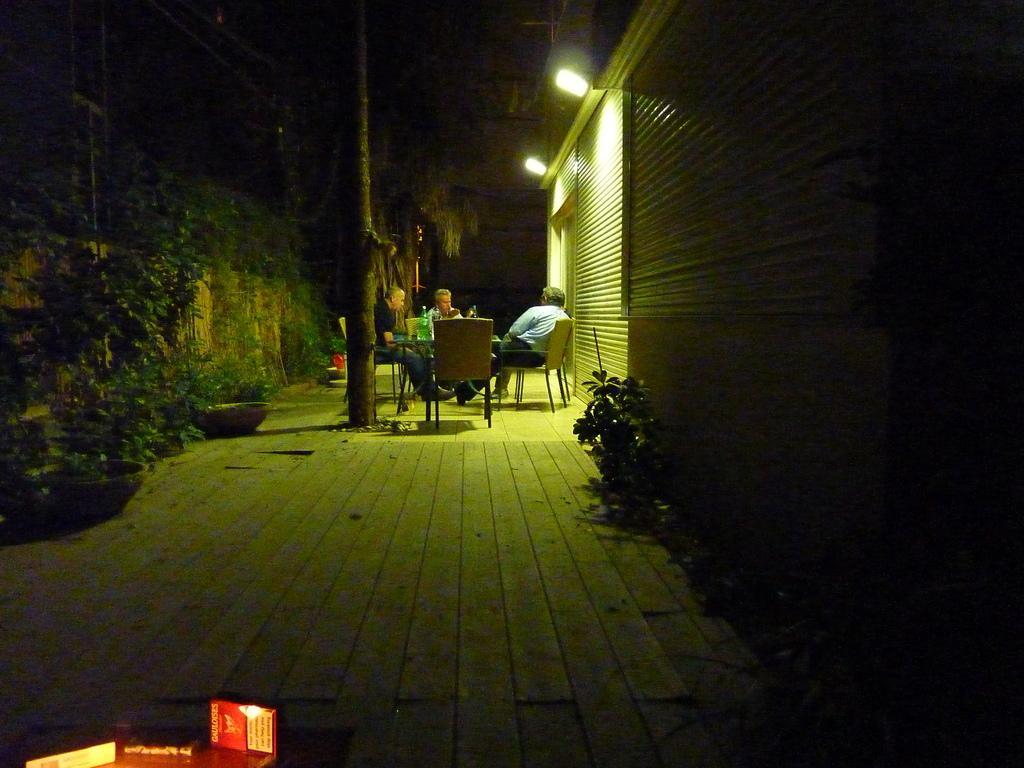Describe this image in one or two sentences. As we can see in the image there are buildings, lights, plants, few people sitting on chairs, trees and table. On table there is a bottle. The image is little dark. 